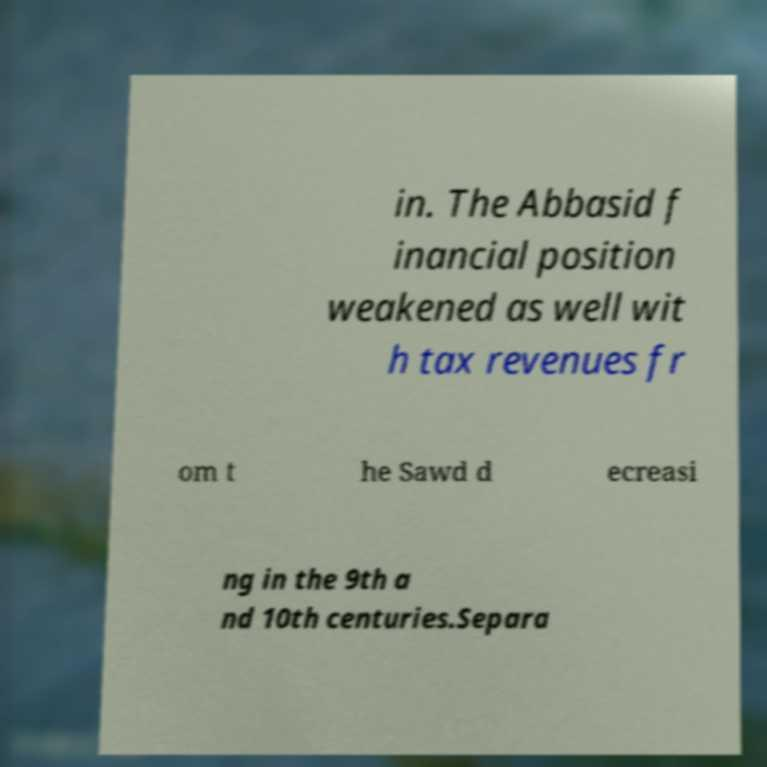For documentation purposes, I need the text within this image transcribed. Could you provide that? in. The Abbasid f inancial position weakened as well wit h tax revenues fr om t he Sawd d ecreasi ng in the 9th a nd 10th centuries.Separa 